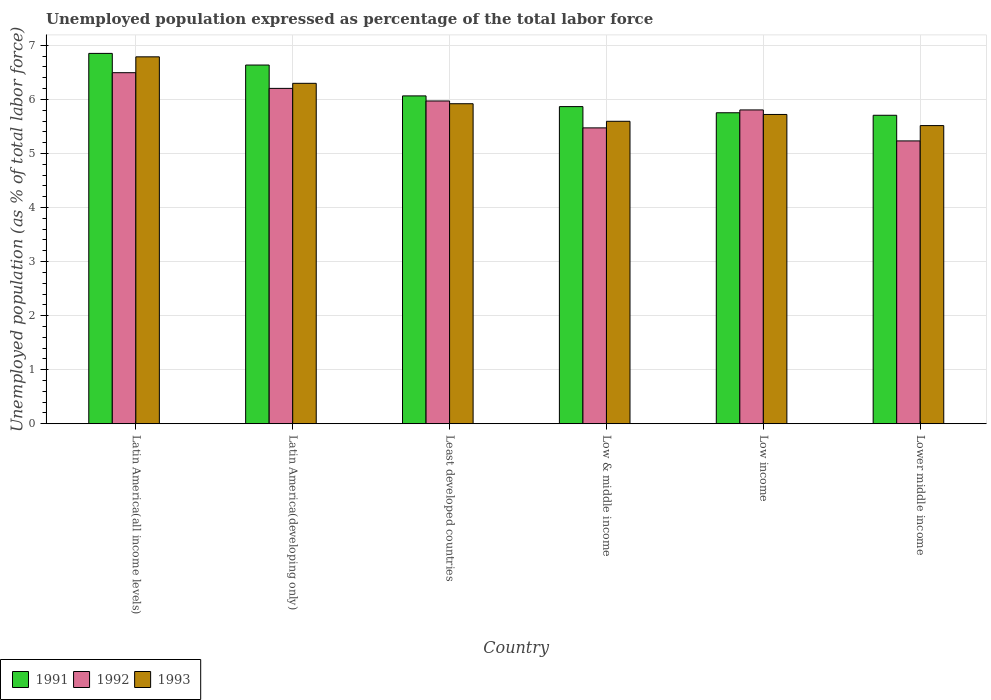How many groups of bars are there?
Keep it short and to the point. 6. Are the number of bars per tick equal to the number of legend labels?
Provide a short and direct response. Yes. How many bars are there on the 3rd tick from the right?
Give a very brief answer. 3. What is the label of the 2nd group of bars from the left?
Your answer should be very brief. Latin America(developing only). What is the unemployment in in 1992 in Least developed countries?
Provide a short and direct response. 5.97. Across all countries, what is the maximum unemployment in in 1993?
Offer a very short reply. 6.79. Across all countries, what is the minimum unemployment in in 1993?
Keep it short and to the point. 5.52. In which country was the unemployment in in 1992 maximum?
Provide a short and direct response. Latin America(all income levels). In which country was the unemployment in in 1993 minimum?
Make the answer very short. Lower middle income. What is the total unemployment in in 1991 in the graph?
Keep it short and to the point. 36.88. What is the difference between the unemployment in in 1991 in Latin America(developing only) and that in Low income?
Your answer should be very brief. 0.88. What is the difference between the unemployment in in 1993 in Low & middle income and the unemployment in in 1991 in Lower middle income?
Make the answer very short. -0.11. What is the average unemployment in in 1991 per country?
Ensure brevity in your answer.  6.15. What is the difference between the unemployment in of/in 1991 and unemployment in of/in 1993 in Low & middle income?
Ensure brevity in your answer.  0.27. What is the ratio of the unemployment in in 1991 in Latin America(all income levels) to that in Lower middle income?
Give a very brief answer. 1.2. Is the unemployment in in 1992 in Latin America(developing only) less than that in Low & middle income?
Provide a short and direct response. No. What is the difference between the highest and the second highest unemployment in in 1992?
Ensure brevity in your answer.  -0.52. What is the difference between the highest and the lowest unemployment in in 1993?
Provide a short and direct response. 1.27. In how many countries, is the unemployment in in 1991 greater than the average unemployment in in 1991 taken over all countries?
Provide a succinct answer. 2. How many countries are there in the graph?
Provide a succinct answer. 6. What is the difference between two consecutive major ticks on the Y-axis?
Your answer should be very brief. 1. Does the graph contain grids?
Provide a short and direct response. Yes. What is the title of the graph?
Provide a short and direct response. Unemployed population expressed as percentage of the total labor force. Does "1988" appear as one of the legend labels in the graph?
Give a very brief answer. No. What is the label or title of the Y-axis?
Make the answer very short. Unemployed population (as % of total labor force). What is the Unemployed population (as % of total labor force) of 1991 in Latin America(all income levels)?
Your response must be concise. 6.85. What is the Unemployed population (as % of total labor force) of 1992 in Latin America(all income levels)?
Make the answer very short. 6.49. What is the Unemployed population (as % of total labor force) of 1993 in Latin America(all income levels)?
Make the answer very short. 6.79. What is the Unemployed population (as % of total labor force) in 1991 in Latin America(developing only)?
Give a very brief answer. 6.64. What is the Unemployed population (as % of total labor force) of 1992 in Latin America(developing only)?
Ensure brevity in your answer.  6.2. What is the Unemployed population (as % of total labor force) in 1993 in Latin America(developing only)?
Offer a terse response. 6.3. What is the Unemployed population (as % of total labor force) in 1991 in Least developed countries?
Offer a terse response. 6.07. What is the Unemployed population (as % of total labor force) in 1992 in Least developed countries?
Your answer should be compact. 5.97. What is the Unemployed population (as % of total labor force) of 1993 in Least developed countries?
Give a very brief answer. 5.92. What is the Unemployed population (as % of total labor force) in 1991 in Low & middle income?
Offer a very short reply. 5.87. What is the Unemployed population (as % of total labor force) of 1992 in Low & middle income?
Ensure brevity in your answer.  5.47. What is the Unemployed population (as % of total labor force) in 1993 in Low & middle income?
Your response must be concise. 5.6. What is the Unemployed population (as % of total labor force) of 1991 in Low income?
Keep it short and to the point. 5.75. What is the Unemployed population (as % of total labor force) of 1992 in Low income?
Keep it short and to the point. 5.81. What is the Unemployed population (as % of total labor force) of 1993 in Low income?
Offer a very short reply. 5.72. What is the Unemployed population (as % of total labor force) of 1991 in Lower middle income?
Your response must be concise. 5.71. What is the Unemployed population (as % of total labor force) in 1992 in Lower middle income?
Offer a terse response. 5.23. What is the Unemployed population (as % of total labor force) in 1993 in Lower middle income?
Your answer should be compact. 5.52. Across all countries, what is the maximum Unemployed population (as % of total labor force) of 1991?
Keep it short and to the point. 6.85. Across all countries, what is the maximum Unemployed population (as % of total labor force) in 1992?
Your answer should be compact. 6.49. Across all countries, what is the maximum Unemployed population (as % of total labor force) in 1993?
Keep it short and to the point. 6.79. Across all countries, what is the minimum Unemployed population (as % of total labor force) of 1991?
Offer a terse response. 5.71. Across all countries, what is the minimum Unemployed population (as % of total labor force) of 1992?
Ensure brevity in your answer.  5.23. Across all countries, what is the minimum Unemployed population (as % of total labor force) in 1993?
Ensure brevity in your answer.  5.52. What is the total Unemployed population (as % of total labor force) in 1991 in the graph?
Offer a very short reply. 36.88. What is the total Unemployed population (as % of total labor force) in 1992 in the graph?
Your answer should be compact. 35.18. What is the total Unemployed population (as % of total labor force) of 1993 in the graph?
Provide a succinct answer. 35.84. What is the difference between the Unemployed population (as % of total labor force) in 1991 in Latin America(all income levels) and that in Latin America(developing only)?
Your answer should be compact. 0.22. What is the difference between the Unemployed population (as % of total labor force) of 1992 in Latin America(all income levels) and that in Latin America(developing only)?
Offer a very short reply. 0.29. What is the difference between the Unemployed population (as % of total labor force) of 1993 in Latin America(all income levels) and that in Latin America(developing only)?
Your response must be concise. 0.49. What is the difference between the Unemployed population (as % of total labor force) of 1991 in Latin America(all income levels) and that in Least developed countries?
Provide a succinct answer. 0.79. What is the difference between the Unemployed population (as % of total labor force) in 1992 in Latin America(all income levels) and that in Least developed countries?
Offer a very short reply. 0.52. What is the difference between the Unemployed population (as % of total labor force) in 1993 in Latin America(all income levels) and that in Least developed countries?
Your answer should be very brief. 0.87. What is the difference between the Unemployed population (as % of total labor force) in 1991 in Latin America(all income levels) and that in Low & middle income?
Provide a succinct answer. 0.98. What is the difference between the Unemployed population (as % of total labor force) of 1992 in Latin America(all income levels) and that in Low & middle income?
Give a very brief answer. 1.02. What is the difference between the Unemployed population (as % of total labor force) in 1993 in Latin America(all income levels) and that in Low & middle income?
Your response must be concise. 1.19. What is the difference between the Unemployed population (as % of total labor force) in 1991 in Latin America(all income levels) and that in Low income?
Give a very brief answer. 1.1. What is the difference between the Unemployed population (as % of total labor force) in 1992 in Latin America(all income levels) and that in Low income?
Give a very brief answer. 0.69. What is the difference between the Unemployed population (as % of total labor force) in 1993 in Latin America(all income levels) and that in Low income?
Provide a short and direct response. 1.07. What is the difference between the Unemployed population (as % of total labor force) in 1991 in Latin America(all income levels) and that in Lower middle income?
Your answer should be compact. 1.14. What is the difference between the Unemployed population (as % of total labor force) in 1992 in Latin America(all income levels) and that in Lower middle income?
Your response must be concise. 1.26. What is the difference between the Unemployed population (as % of total labor force) of 1993 in Latin America(all income levels) and that in Lower middle income?
Your response must be concise. 1.27. What is the difference between the Unemployed population (as % of total labor force) in 1991 in Latin America(developing only) and that in Least developed countries?
Make the answer very short. 0.57. What is the difference between the Unemployed population (as % of total labor force) of 1992 in Latin America(developing only) and that in Least developed countries?
Keep it short and to the point. 0.23. What is the difference between the Unemployed population (as % of total labor force) of 1993 in Latin America(developing only) and that in Least developed countries?
Ensure brevity in your answer.  0.38. What is the difference between the Unemployed population (as % of total labor force) of 1991 in Latin America(developing only) and that in Low & middle income?
Offer a terse response. 0.77. What is the difference between the Unemployed population (as % of total labor force) in 1992 in Latin America(developing only) and that in Low & middle income?
Ensure brevity in your answer.  0.73. What is the difference between the Unemployed population (as % of total labor force) of 1993 in Latin America(developing only) and that in Low & middle income?
Provide a short and direct response. 0.7. What is the difference between the Unemployed population (as % of total labor force) in 1991 in Latin America(developing only) and that in Low income?
Ensure brevity in your answer.  0.88. What is the difference between the Unemployed population (as % of total labor force) in 1992 in Latin America(developing only) and that in Low income?
Ensure brevity in your answer.  0.4. What is the difference between the Unemployed population (as % of total labor force) of 1993 in Latin America(developing only) and that in Low income?
Make the answer very short. 0.58. What is the difference between the Unemployed population (as % of total labor force) in 1991 in Latin America(developing only) and that in Lower middle income?
Your response must be concise. 0.93. What is the difference between the Unemployed population (as % of total labor force) in 1992 in Latin America(developing only) and that in Lower middle income?
Ensure brevity in your answer.  0.97. What is the difference between the Unemployed population (as % of total labor force) of 1993 in Latin America(developing only) and that in Lower middle income?
Provide a short and direct response. 0.78. What is the difference between the Unemployed population (as % of total labor force) in 1991 in Least developed countries and that in Low & middle income?
Your answer should be very brief. 0.2. What is the difference between the Unemployed population (as % of total labor force) of 1992 in Least developed countries and that in Low & middle income?
Keep it short and to the point. 0.5. What is the difference between the Unemployed population (as % of total labor force) of 1993 in Least developed countries and that in Low & middle income?
Your answer should be compact. 0.32. What is the difference between the Unemployed population (as % of total labor force) of 1991 in Least developed countries and that in Low income?
Give a very brief answer. 0.31. What is the difference between the Unemployed population (as % of total labor force) of 1992 in Least developed countries and that in Low income?
Ensure brevity in your answer.  0.17. What is the difference between the Unemployed population (as % of total labor force) of 1993 in Least developed countries and that in Low income?
Ensure brevity in your answer.  0.2. What is the difference between the Unemployed population (as % of total labor force) in 1991 in Least developed countries and that in Lower middle income?
Offer a terse response. 0.36. What is the difference between the Unemployed population (as % of total labor force) in 1992 in Least developed countries and that in Lower middle income?
Give a very brief answer. 0.74. What is the difference between the Unemployed population (as % of total labor force) in 1993 in Least developed countries and that in Lower middle income?
Offer a terse response. 0.4. What is the difference between the Unemployed population (as % of total labor force) of 1991 in Low & middle income and that in Low income?
Ensure brevity in your answer.  0.11. What is the difference between the Unemployed population (as % of total labor force) in 1992 in Low & middle income and that in Low income?
Keep it short and to the point. -0.33. What is the difference between the Unemployed population (as % of total labor force) of 1993 in Low & middle income and that in Low income?
Offer a terse response. -0.13. What is the difference between the Unemployed population (as % of total labor force) of 1991 in Low & middle income and that in Lower middle income?
Offer a very short reply. 0.16. What is the difference between the Unemployed population (as % of total labor force) in 1992 in Low & middle income and that in Lower middle income?
Provide a succinct answer. 0.24. What is the difference between the Unemployed population (as % of total labor force) in 1993 in Low & middle income and that in Lower middle income?
Your answer should be compact. 0.08. What is the difference between the Unemployed population (as % of total labor force) of 1991 in Low income and that in Lower middle income?
Ensure brevity in your answer.  0.05. What is the difference between the Unemployed population (as % of total labor force) of 1992 in Low income and that in Lower middle income?
Offer a terse response. 0.57. What is the difference between the Unemployed population (as % of total labor force) of 1993 in Low income and that in Lower middle income?
Offer a terse response. 0.21. What is the difference between the Unemployed population (as % of total labor force) of 1991 in Latin America(all income levels) and the Unemployed population (as % of total labor force) of 1992 in Latin America(developing only)?
Offer a terse response. 0.65. What is the difference between the Unemployed population (as % of total labor force) in 1991 in Latin America(all income levels) and the Unemployed population (as % of total labor force) in 1993 in Latin America(developing only)?
Keep it short and to the point. 0.55. What is the difference between the Unemployed population (as % of total labor force) in 1992 in Latin America(all income levels) and the Unemployed population (as % of total labor force) in 1993 in Latin America(developing only)?
Ensure brevity in your answer.  0.2. What is the difference between the Unemployed population (as % of total labor force) in 1991 in Latin America(all income levels) and the Unemployed population (as % of total labor force) in 1992 in Least developed countries?
Offer a terse response. 0.88. What is the difference between the Unemployed population (as % of total labor force) of 1991 in Latin America(all income levels) and the Unemployed population (as % of total labor force) of 1993 in Least developed countries?
Keep it short and to the point. 0.93. What is the difference between the Unemployed population (as % of total labor force) of 1992 in Latin America(all income levels) and the Unemployed population (as % of total labor force) of 1993 in Least developed countries?
Your response must be concise. 0.57. What is the difference between the Unemployed population (as % of total labor force) of 1991 in Latin America(all income levels) and the Unemployed population (as % of total labor force) of 1992 in Low & middle income?
Ensure brevity in your answer.  1.38. What is the difference between the Unemployed population (as % of total labor force) in 1991 in Latin America(all income levels) and the Unemployed population (as % of total labor force) in 1993 in Low & middle income?
Make the answer very short. 1.26. What is the difference between the Unemployed population (as % of total labor force) in 1992 in Latin America(all income levels) and the Unemployed population (as % of total labor force) in 1993 in Low & middle income?
Give a very brief answer. 0.9. What is the difference between the Unemployed population (as % of total labor force) of 1991 in Latin America(all income levels) and the Unemployed population (as % of total labor force) of 1992 in Low income?
Make the answer very short. 1.05. What is the difference between the Unemployed population (as % of total labor force) in 1991 in Latin America(all income levels) and the Unemployed population (as % of total labor force) in 1993 in Low income?
Provide a succinct answer. 1.13. What is the difference between the Unemployed population (as % of total labor force) in 1992 in Latin America(all income levels) and the Unemployed population (as % of total labor force) in 1993 in Low income?
Make the answer very short. 0.77. What is the difference between the Unemployed population (as % of total labor force) of 1991 in Latin America(all income levels) and the Unemployed population (as % of total labor force) of 1992 in Lower middle income?
Provide a short and direct response. 1.62. What is the difference between the Unemployed population (as % of total labor force) of 1991 in Latin America(all income levels) and the Unemployed population (as % of total labor force) of 1993 in Lower middle income?
Your response must be concise. 1.34. What is the difference between the Unemployed population (as % of total labor force) of 1992 in Latin America(all income levels) and the Unemployed population (as % of total labor force) of 1993 in Lower middle income?
Offer a terse response. 0.98. What is the difference between the Unemployed population (as % of total labor force) of 1991 in Latin America(developing only) and the Unemployed population (as % of total labor force) of 1992 in Least developed countries?
Ensure brevity in your answer.  0.66. What is the difference between the Unemployed population (as % of total labor force) in 1991 in Latin America(developing only) and the Unemployed population (as % of total labor force) in 1993 in Least developed countries?
Keep it short and to the point. 0.72. What is the difference between the Unemployed population (as % of total labor force) of 1992 in Latin America(developing only) and the Unemployed population (as % of total labor force) of 1993 in Least developed countries?
Give a very brief answer. 0.28. What is the difference between the Unemployed population (as % of total labor force) of 1991 in Latin America(developing only) and the Unemployed population (as % of total labor force) of 1992 in Low & middle income?
Make the answer very short. 1.16. What is the difference between the Unemployed population (as % of total labor force) of 1991 in Latin America(developing only) and the Unemployed population (as % of total labor force) of 1993 in Low & middle income?
Provide a succinct answer. 1.04. What is the difference between the Unemployed population (as % of total labor force) in 1992 in Latin America(developing only) and the Unemployed population (as % of total labor force) in 1993 in Low & middle income?
Offer a very short reply. 0.61. What is the difference between the Unemployed population (as % of total labor force) in 1991 in Latin America(developing only) and the Unemployed population (as % of total labor force) in 1992 in Low income?
Your response must be concise. 0.83. What is the difference between the Unemployed population (as % of total labor force) in 1991 in Latin America(developing only) and the Unemployed population (as % of total labor force) in 1993 in Low income?
Provide a short and direct response. 0.91. What is the difference between the Unemployed population (as % of total labor force) of 1992 in Latin America(developing only) and the Unemployed population (as % of total labor force) of 1993 in Low income?
Your answer should be very brief. 0.48. What is the difference between the Unemployed population (as % of total labor force) in 1991 in Latin America(developing only) and the Unemployed population (as % of total labor force) in 1992 in Lower middle income?
Offer a terse response. 1.4. What is the difference between the Unemployed population (as % of total labor force) in 1991 in Latin America(developing only) and the Unemployed population (as % of total labor force) in 1993 in Lower middle income?
Your answer should be compact. 1.12. What is the difference between the Unemployed population (as % of total labor force) in 1992 in Latin America(developing only) and the Unemployed population (as % of total labor force) in 1993 in Lower middle income?
Provide a short and direct response. 0.69. What is the difference between the Unemployed population (as % of total labor force) of 1991 in Least developed countries and the Unemployed population (as % of total labor force) of 1992 in Low & middle income?
Keep it short and to the point. 0.59. What is the difference between the Unemployed population (as % of total labor force) of 1991 in Least developed countries and the Unemployed population (as % of total labor force) of 1993 in Low & middle income?
Your answer should be very brief. 0.47. What is the difference between the Unemployed population (as % of total labor force) in 1992 in Least developed countries and the Unemployed population (as % of total labor force) in 1993 in Low & middle income?
Offer a terse response. 0.38. What is the difference between the Unemployed population (as % of total labor force) in 1991 in Least developed countries and the Unemployed population (as % of total labor force) in 1992 in Low income?
Your answer should be very brief. 0.26. What is the difference between the Unemployed population (as % of total labor force) of 1991 in Least developed countries and the Unemployed population (as % of total labor force) of 1993 in Low income?
Offer a very short reply. 0.34. What is the difference between the Unemployed population (as % of total labor force) in 1992 in Least developed countries and the Unemployed population (as % of total labor force) in 1993 in Low income?
Your answer should be compact. 0.25. What is the difference between the Unemployed population (as % of total labor force) of 1991 in Least developed countries and the Unemployed population (as % of total labor force) of 1992 in Lower middle income?
Your response must be concise. 0.83. What is the difference between the Unemployed population (as % of total labor force) of 1991 in Least developed countries and the Unemployed population (as % of total labor force) of 1993 in Lower middle income?
Ensure brevity in your answer.  0.55. What is the difference between the Unemployed population (as % of total labor force) in 1992 in Least developed countries and the Unemployed population (as % of total labor force) in 1993 in Lower middle income?
Make the answer very short. 0.46. What is the difference between the Unemployed population (as % of total labor force) of 1991 in Low & middle income and the Unemployed population (as % of total labor force) of 1992 in Low income?
Your answer should be compact. 0.06. What is the difference between the Unemployed population (as % of total labor force) of 1991 in Low & middle income and the Unemployed population (as % of total labor force) of 1993 in Low income?
Your answer should be very brief. 0.15. What is the difference between the Unemployed population (as % of total labor force) in 1992 in Low & middle income and the Unemployed population (as % of total labor force) in 1993 in Low income?
Ensure brevity in your answer.  -0.25. What is the difference between the Unemployed population (as % of total labor force) in 1991 in Low & middle income and the Unemployed population (as % of total labor force) in 1992 in Lower middle income?
Your answer should be very brief. 0.63. What is the difference between the Unemployed population (as % of total labor force) in 1991 in Low & middle income and the Unemployed population (as % of total labor force) in 1993 in Lower middle income?
Keep it short and to the point. 0.35. What is the difference between the Unemployed population (as % of total labor force) of 1992 in Low & middle income and the Unemployed population (as % of total labor force) of 1993 in Lower middle income?
Provide a succinct answer. -0.04. What is the difference between the Unemployed population (as % of total labor force) of 1991 in Low income and the Unemployed population (as % of total labor force) of 1992 in Lower middle income?
Your answer should be very brief. 0.52. What is the difference between the Unemployed population (as % of total labor force) in 1991 in Low income and the Unemployed population (as % of total labor force) in 1993 in Lower middle income?
Make the answer very short. 0.24. What is the difference between the Unemployed population (as % of total labor force) in 1992 in Low income and the Unemployed population (as % of total labor force) in 1993 in Lower middle income?
Your answer should be very brief. 0.29. What is the average Unemployed population (as % of total labor force) in 1991 per country?
Ensure brevity in your answer.  6.15. What is the average Unemployed population (as % of total labor force) in 1992 per country?
Make the answer very short. 5.86. What is the average Unemployed population (as % of total labor force) in 1993 per country?
Your answer should be compact. 5.97. What is the difference between the Unemployed population (as % of total labor force) of 1991 and Unemployed population (as % of total labor force) of 1992 in Latin America(all income levels)?
Offer a very short reply. 0.36. What is the difference between the Unemployed population (as % of total labor force) in 1991 and Unemployed population (as % of total labor force) in 1993 in Latin America(all income levels)?
Your response must be concise. 0.06. What is the difference between the Unemployed population (as % of total labor force) of 1992 and Unemployed population (as % of total labor force) of 1993 in Latin America(all income levels)?
Your answer should be compact. -0.29. What is the difference between the Unemployed population (as % of total labor force) of 1991 and Unemployed population (as % of total labor force) of 1992 in Latin America(developing only)?
Keep it short and to the point. 0.43. What is the difference between the Unemployed population (as % of total labor force) in 1991 and Unemployed population (as % of total labor force) in 1993 in Latin America(developing only)?
Offer a very short reply. 0.34. What is the difference between the Unemployed population (as % of total labor force) in 1992 and Unemployed population (as % of total labor force) in 1993 in Latin America(developing only)?
Keep it short and to the point. -0.09. What is the difference between the Unemployed population (as % of total labor force) in 1991 and Unemployed population (as % of total labor force) in 1992 in Least developed countries?
Your answer should be very brief. 0.09. What is the difference between the Unemployed population (as % of total labor force) in 1991 and Unemployed population (as % of total labor force) in 1993 in Least developed countries?
Give a very brief answer. 0.14. What is the difference between the Unemployed population (as % of total labor force) in 1992 and Unemployed population (as % of total labor force) in 1993 in Least developed countries?
Provide a short and direct response. 0.05. What is the difference between the Unemployed population (as % of total labor force) of 1991 and Unemployed population (as % of total labor force) of 1992 in Low & middle income?
Provide a succinct answer. 0.39. What is the difference between the Unemployed population (as % of total labor force) in 1991 and Unemployed population (as % of total labor force) in 1993 in Low & middle income?
Ensure brevity in your answer.  0.27. What is the difference between the Unemployed population (as % of total labor force) of 1992 and Unemployed population (as % of total labor force) of 1993 in Low & middle income?
Your answer should be compact. -0.12. What is the difference between the Unemployed population (as % of total labor force) in 1991 and Unemployed population (as % of total labor force) in 1992 in Low income?
Offer a very short reply. -0.05. What is the difference between the Unemployed population (as % of total labor force) in 1991 and Unemployed population (as % of total labor force) in 1993 in Low income?
Make the answer very short. 0.03. What is the difference between the Unemployed population (as % of total labor force) in 1992 and Unemployed population (as % of total labor force) in 1993 in Low income?
Provide a succinct answer. 0.08. What is the difference between the Unemployed population (as % of total labor force) in 1991 and Unemployed population (as % of total labor force) in 1992 in Lower middle income?
Give a very brief answer. 0.47. What is the difference between the Unemployed population (as % of total labor force) of 1991 and Unemployed population (as % of total labor force) of 1993 in Lower middle income?
Give a very brief answer. 0.19. What is the difference between the Unemployed population (as % of total labor force) in 1992 and Unemployed population (as % of total labor force) in 1993 in Lower middle income?
Offer a very short reply. -0.28. What is the ratio of the Unemployed population (as % of total labor force) in 1991 in Latin America(all income levels) to that in Latin America(developing only)?
Your answer should be compact. 1.03. What is the ratio of the Unemployed population (as % of total labor force) in 1992 in Latin America(all income levels) to that in Latin America(developing only)?
Your answer should be compact. 1.05. What is the ratio of the Unemployed population (as % of total labor force) in 1993 in Latin America(all income levels) to that in Latin America(developing only)?
Offer a terse response. 1.08. What is the ratio of the Unemployed population (as % of total labor force) in 1991 in Latin America(all income levels) to that in Least developed countries?
Your response must be concise. 1.13. What is the ratio of the Unemployed population (as % of total labor force) in 1992 in Latin America(all income levels) to that in Least developed countries?
Keep it short and to the point. 1.09. What is the ratio of the Unemployed population (as % of total labor force) of 1993 in Latin America(all income levels) to that in Least developed countries?
Offer a terse response. 1.15. What is the ratio of the Unemployed population (as % of total labor force) of 1991 in Latin America(all income levels) to that in Low & middle income?
Ensure brevity in your answer.  1.17. What is the ratio of the Unemployed population (as % of total labor force) in 1992 in Latin America(all income levels) to that in Low & middle income?
Offer a terse response. 1.19. What is the ratio of the Unemployed population (as % of total labor force) in 1993 in Latin America(all income levels) to that in Low & middle income?
Keep it short and to the point. 1.21. What is the ratio of the Unemployed population (as % of total labor force) in 1991 in Latin America(all income levels) to that in Low income?
Your answer should be very brief. 1.19. What is the ratio of the Unemployed population (as % of total labor force) in 1992 in Latin America(all income levels) to that in Low income?
Your answer should be very brief. 1.12. What is the ratio of the Unemployed population (as % of total labor force) of 1993 in Latin America(all income levels) to that in Low income?
Offer a very short reply. 1.19. What is the ratio of the Unemployed population (as % of total labor force) in 1991 in Latin America(all income levels) to that in Lower middle income?
Offer a terse response. 1.2. What is the ratio of the Unemployed population (as % of total labor force) in 1992 in Latin America(all income levels) to that in Lower middle income?
Make the answer very short. 1.24. What is the ratio of the Unemployed population (as % of total labor force) in 1993 in Latin America(all income levels) to that in Lower middle income?
Offer a terse response. 1.23. What is the ratio of the Unemployed population (as % of total labor force) of 1991 in Latin America(developing only) to that in Least developed countries?
Make the answer very short. 1.09. What is the ratio of the Unemployed population (as % of total labor force) of 1992 in Latin America(developing only) to that in Least developed countries?
Provide a succinct answer. 1.04. What is the ratio of the Unemployed population (as % of total labor force) of 1993 in Latin America(developing only) to that in Least developed countries?
Offer a very short reply. 1.06. What is the ratio of the Unemployed population (as % of total labor force) in 1991 in Latin America(developing only) to that in Low & middle income?
Make the answer very short. 1.13. What is the ratio of the Unemployed population (as % of total labor force) of 1992 in Latin America(developing only) to that in Low & middle income?
Offer a very short reply. 1.13. What is the ratio of the Unemployed population (as % of total labor force) in 1993 in Latin America(developing only) to that in Low & middle income?
Keep it short and to the point. 1.13. What is the ratio of the Unemployed population (as % of total labor force) in 1991 in Latin America(developing only) to that in Low income?
Ensure brevity in your answer.  1.15. What is the ratio of the Unemployed population (as % of total labor force) in 1992 in Latin America(developing only) to that in Low income?
Make the answer very short. 1.07. What is the ratio of the Unemployed population (as % of total labor force) in 1993 in Latin America(developing only) to that in Low income?
Your answer should be compact. 1.1. What is the ratio of the Unemployed population (as % of total labor force) of 1991 in Latin America(developing only) to that in Lower middle income?
Provide a short and direct response. 1.16. What is the ratio of the Unemployed population (as % of total labor force) in 1992 in Latin America(developing only) to that in Lower middle income?
Your answer should be compact. 1.19. What is the ratio of the Unemployed population (as % of total labor force) in 1993 in Latin America(developing only) to that in Lower middle income?
Your answer should be compact. 1.14. What is the ratio of the Unemployed population (as % of total labor force) of 1991 in Least developed countries to that in Low & middle income?
Your answer should be very brief. 1.03. What is the ratio of the Unemployed population (as % of total labor force) of 1992 in Least developed countries to that in Low & middle income?
Provide a short and direct response. 1.09. What is the ratio of the Unemployed population (as % of total labor force) of 1993 in Least developed countries to that in Low & middle income?
Give a very brief answer. 1.06. What is the ratio of the Unemployed population (as % of total labor force) of 1991 in Least developed countries to that in Low income?
Give a very brief answer. 1.05. What is the ratio of the Unemployed population (as % of total labor force) in 1992 in Least developed countries to that in Low income?
Make the answer very short. 1.03. What is the ratio of the Unemployed population (as % of total labor force) of 1993 in Least developed countries to that in Low income?
Make the answer very short. 1.03. What is the ratio of the Unemployed population (as % of total labor force) of 1991 in Least developed countries to that in Lower middle income?
Offer a very short reply. 1.06. What is the ratio of the Unemployed population (as % of total labor force) in 1992 in Least developed countries to that in Lower middle income?
Keep it short and to the point. 1.14. What is the ratio of the Unemployed population (as % of total labor force) in 1993 in Least developed countries to that in Lower middle income?
Provide a short and direct response. 1.07. What is the ratio of the Unemployed population (as % of total labor force) of 1991 in Low & middle income to that in Low income?
Provide a short and direct response. 1.02. What is the ratio of the Unemployed population (as % of total labor force) of 1992 in Low & middle income to that in Low income?
Your answer should be compact. 0.94. What is the ratio of the Unemployed population (as % of total labor force) in 1993 in Low & middle income to that in Low income?
Provide a short and direct response. 0.98. What is the ratio of the Unemployed population (as % of total labor force) of 1991 in Low & middle income to that in Lower middle income?
Your answer should be very brief. 1.03. What is the ratio of the Unemployed population (as % of total labor force) of 1992 in Low & middle income to that in Lower middle income?
Keep it short and to the point. 1.05. What is the ratio of the Unemployed population (as % of total labor force) in 1993 in Low & middle income to that in Lower middle income?
Ensure brevity in your answer.  1.01. What is the ratio of the Unemployed population (as % of total labor force) of 1991 in Low income to that in Lower middle income?
Provide a succinct answer. 1.01. What is the ratio of the Unemployed population (as % of total labor force) of 1992 in Low income to that in Lower middle income?
Make the answer very short. 1.11. What is the ratio of the Unemployed population (as % of total labor force) of 1993 in Low income to that in Lower middle income?
Offer a terse response. 1.04. What is the difference between the highest and the second highest Unemployed population (as % of total labor force) in 1991?
Your answer should be very brief. 0.22. What is the difference between the highest and the second highest Unemployed population (as % of total labor force) in 1992?
Provide a succinct answer. 0.29. What is the difference between the highest and the second highest Unemployed population (as % of total labor force) of 1993?
Give a very brief answer. 0.49. What is the difference between the highest and the lowest Unemployed population (as % of total labor force) of 1991?
Make the answer very short. 1.14. What is the difference between the highest and the lowest Unemployed population (as % of total labor force) of 1992?
Your answer should be compact. 1.26. What is the difference between the highest and the lowest Unemployed population (as % of total labor force) in 1993?
Provide a succinct answer. 1.27. 